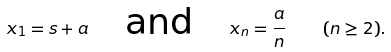Convert formula to latex. <formula><loc_0><loc_0><loc_500><loc_500>x _ { 1 } = s + a \quad \text {and} \quad x _ { n } = \frac { a } { n } \quad ( n \geq 2 ) .</formula> 